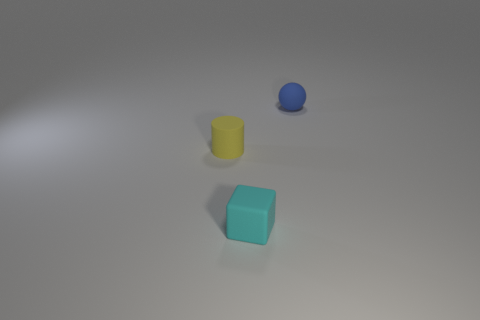What time of day does the lighting in this image suggest? The soft shadows and the neutral background in the image suggest an indoor environment with artificial lighting, rather than natural daylight. It might resemble typical indoor lighting conditions that are constant throughout the day. 